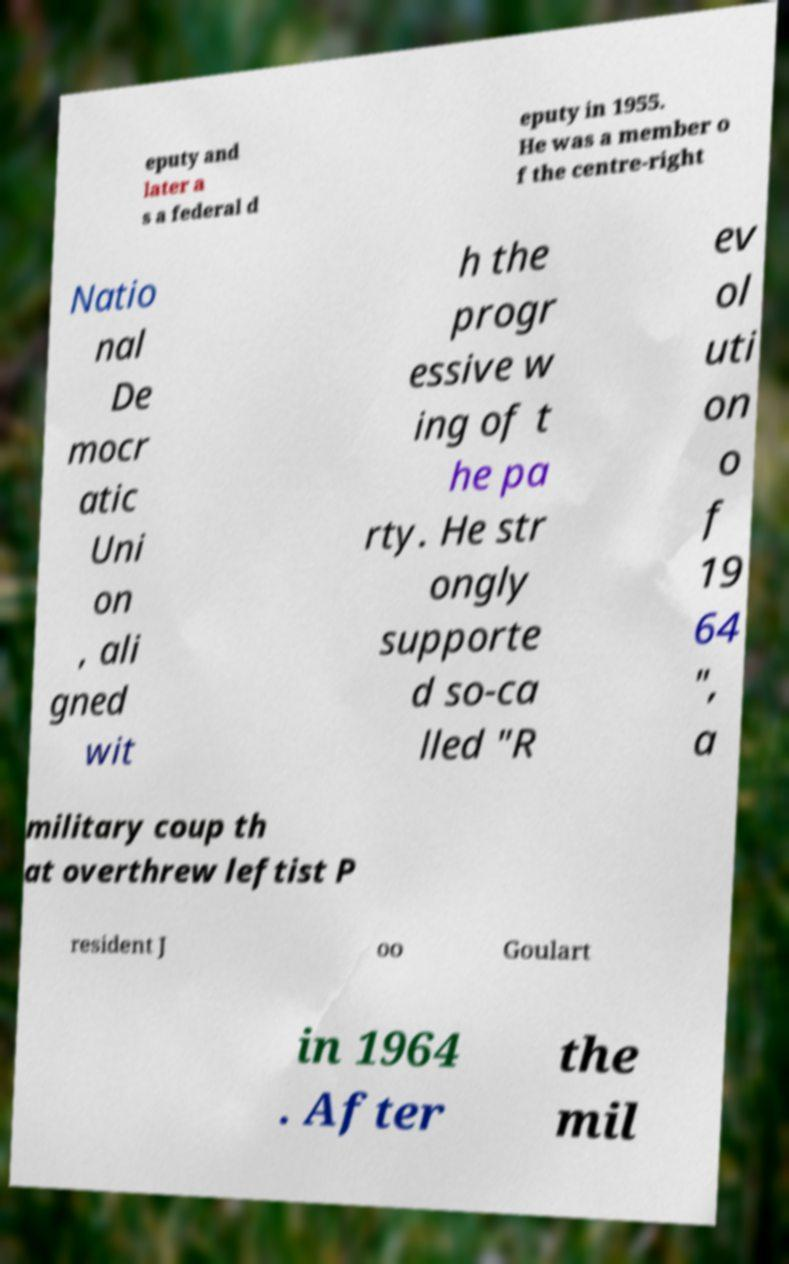Please identify and transcribe the text found in this image. eputy and later a s a federal d eputy in 1955. He was a member o f the centre-right Natio nal De mocr atic Uni on , ali gned wit h the progr essive w ing of t he pa rty. He str ongly supporte d so-ca lled "R ev ol uti on o f 19 64 ", a military coup th at overthrew leftist P resident J oo Goulart in 1964 . After the mil 